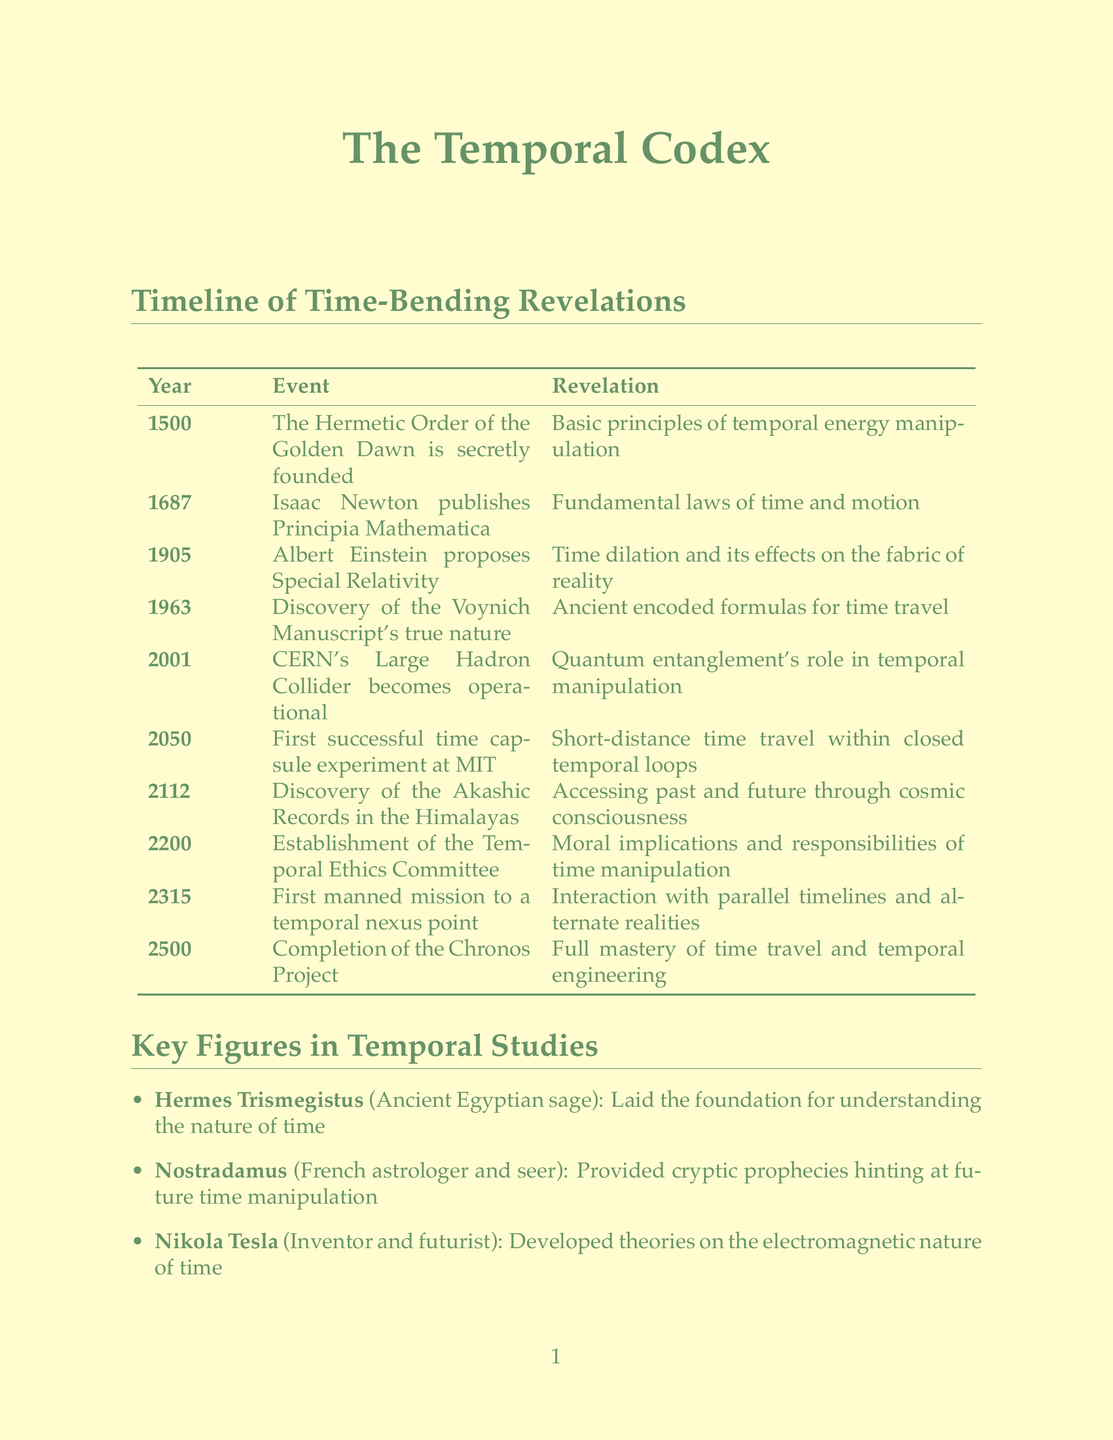What year was the Hermetic Order of the Golden Dawn founded? The document states that the Hermetic Order of the Golden Dawn was secretly founded in 1500.
Answer: 1500 What revelation is associated with Isaac Newton's publication of Principia Mathematica? The document indicates that the fundamental laws of time and motion were revealed with Isaac Newton's publication in 1687.
Answer: Fundamental laws of time and motion What is the name of the sacred artifact located in the Egyptian Museum, Cairo? According to the document, the sacred artifact located in the Egyptian Museum, Cairo is The Emerald Tablets.
Answer: The Emerald Tablets What is the significance of the year 2050 in the timeline? The document notes that in 2050, the first successful time capsule experiment at MIT occurred, revealing short-distance time travel within closed temporal loops.
Answer: Short-distance time travel within closed temporal loops Which key figure is known for exploring the concept of time in relation to black holes? The document mentions that Stephen Hawking explored the concept of time in relation to black holes and the universe.
Answer: Stephen Hawking What does the Law of Temporal Causality describe? The document states that the Law of Temporal Causality describes how every action in time creates ripples that affect both past and future.
Answer: Ripples that affect both past and future In what year does the document state the Chronos Project was completed? The document highlights that the completion of the Chronos Project occurred in the year 2500.
Answer: 2500 What is the power of the Crystal Skull of Akator? The document claims that the power of the Crystal Skull of Akator allows telepathic communication across time.
Answer: Telepathic communication across time 